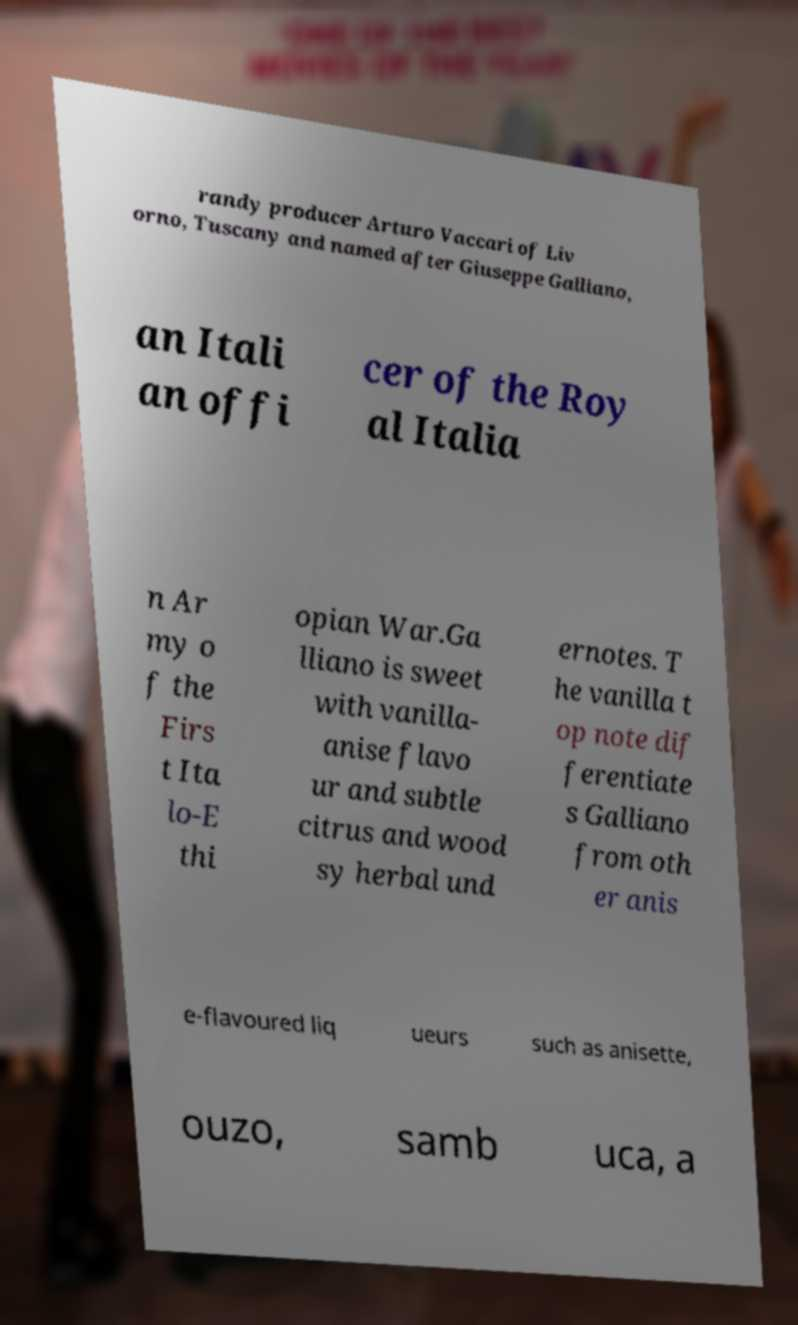Can you accurately transcribe the text from the provided image for me? randy producer Arturo Vaccari of Liv orno, Tuscany and named after Giuseppe Galliano, an Itali an offi cer of the Roy al Italia n Ar my o f the Firs t Ita lo-E thi opian War.Ga lliano is sweet with vanilla- anise flavo ur and subtle citrus and wood sy herbal und ernotes. T he vanilla t op note dif ferentiate s Galliano from oth er anis e-flavoured liq ueurs such as anisette, ouzo, samb uca, a 